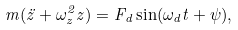Convert formula to latex. <formula><loc_0><loc_0><loc_500><loc_500>m ( \ddot { z } + \omega _ { z } ^ { 2 } z ) = F _ { d } \sin ( \omega _ { d } t + \psi ) ,</formula> 